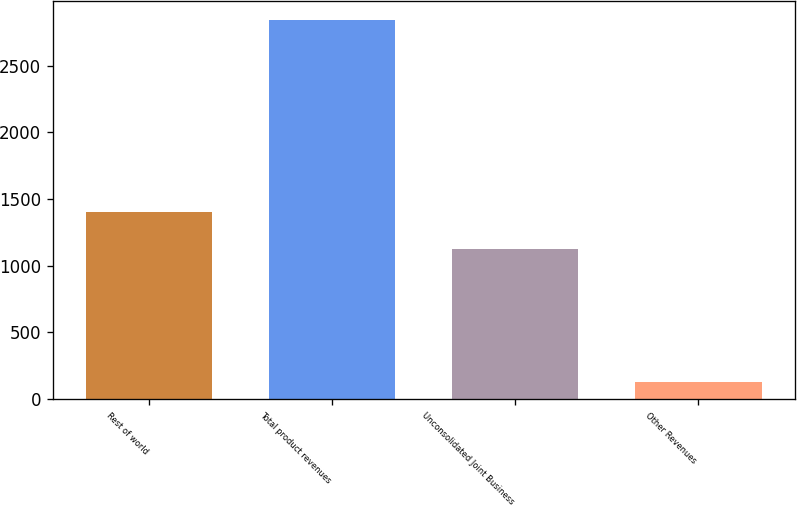Convert chart to OTSL. <chart><loc_0><loc_0><loc_500><loc_500><bar_chart><fcel>Rest of world<fcel>Total product revenues<fcel>Unconsolidated Joint Business<fcel>Other Revenues<nl><fcel>1399.21<fcel>2839.7<fcel>1128.2<fcel>129.6<nl></chart> 